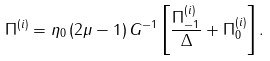<formula> <loc_0><loc_0><loc_500><loc_500>\Pi ^ { ( i ) } = \eta _ { 0 } \, ( 2 \mu - 1 ) \, G ^ { - 1 } \left [ \frac { \Pi ^ { ( i ) } _ { - 1 } } { \Delta } + \Pi ^ { ( i ) } _ { 0 } \right ] .</formula> 